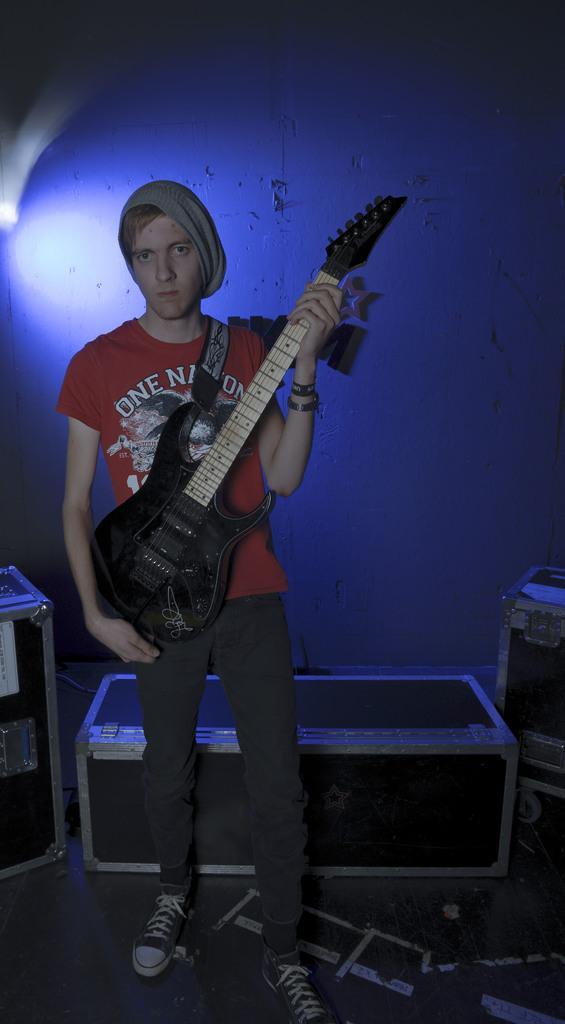How would you summarize this image in a sentence or two? In this image one boy is wearing the guitar and he is wearing the red t-shirt and black pant ash color shoes and hat and Behind the boy some boxes are there back ground is little dark. 